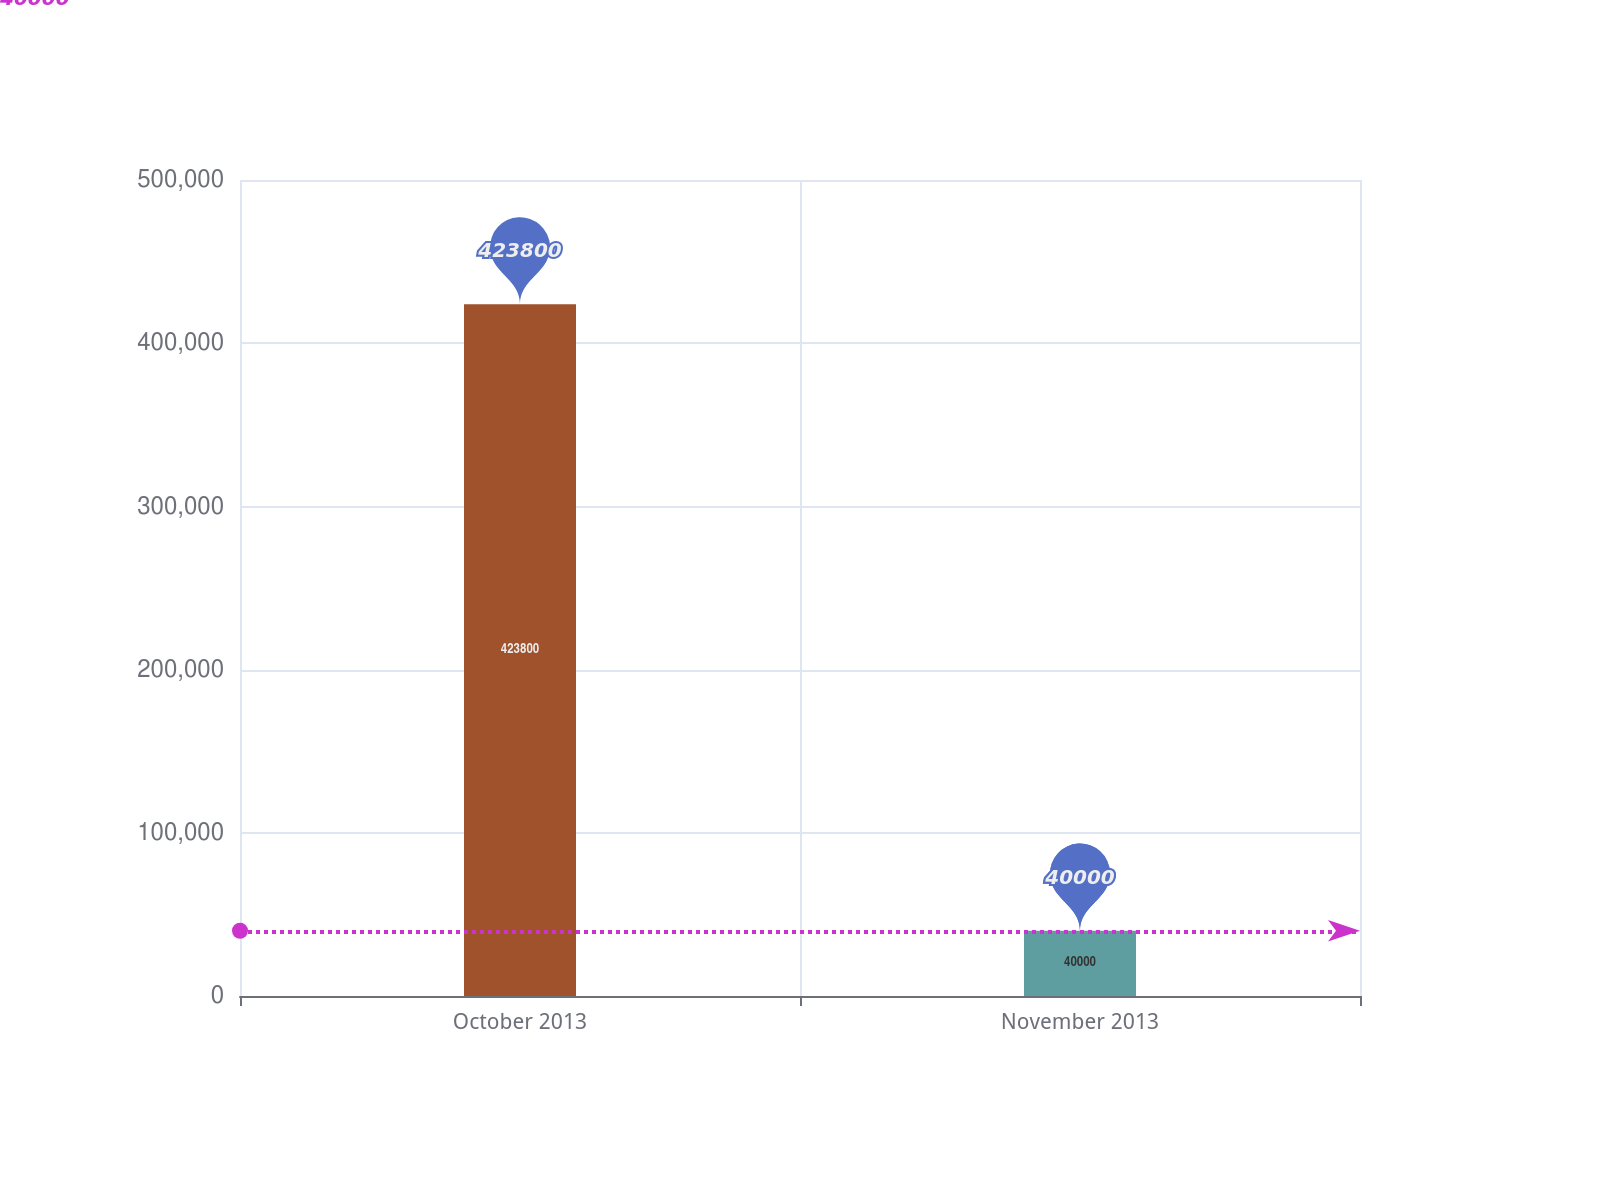<chart> <loc_0><loc_0><loc_500><loc_500><bar_chart><fcel>October 2013<fcel>November 2013<nl><fcel>423800<fcel>40000<nl></chart> 